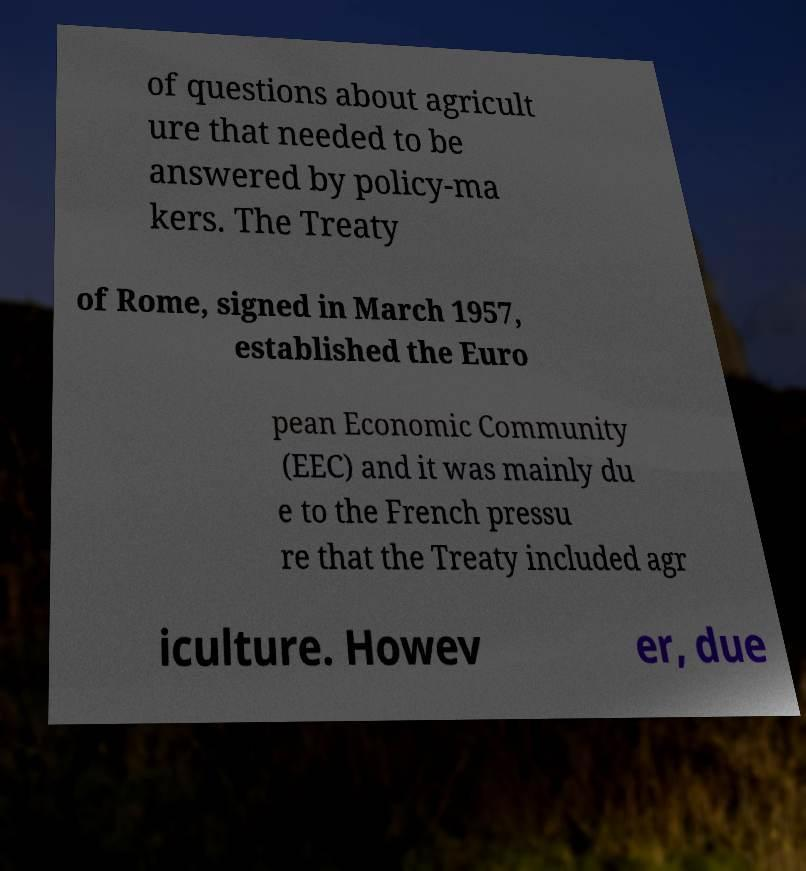Please read and relay the text visible in this image. What does it say? of questions about agricult ure that needed to be answered by policy-ma kers. The Treaty of Rome, signed in March 1957, established the Euro pean Economic Community (EEC) and it was mainly du e to the French pressu re that the Treaty included agr iculture. Howev er, due 